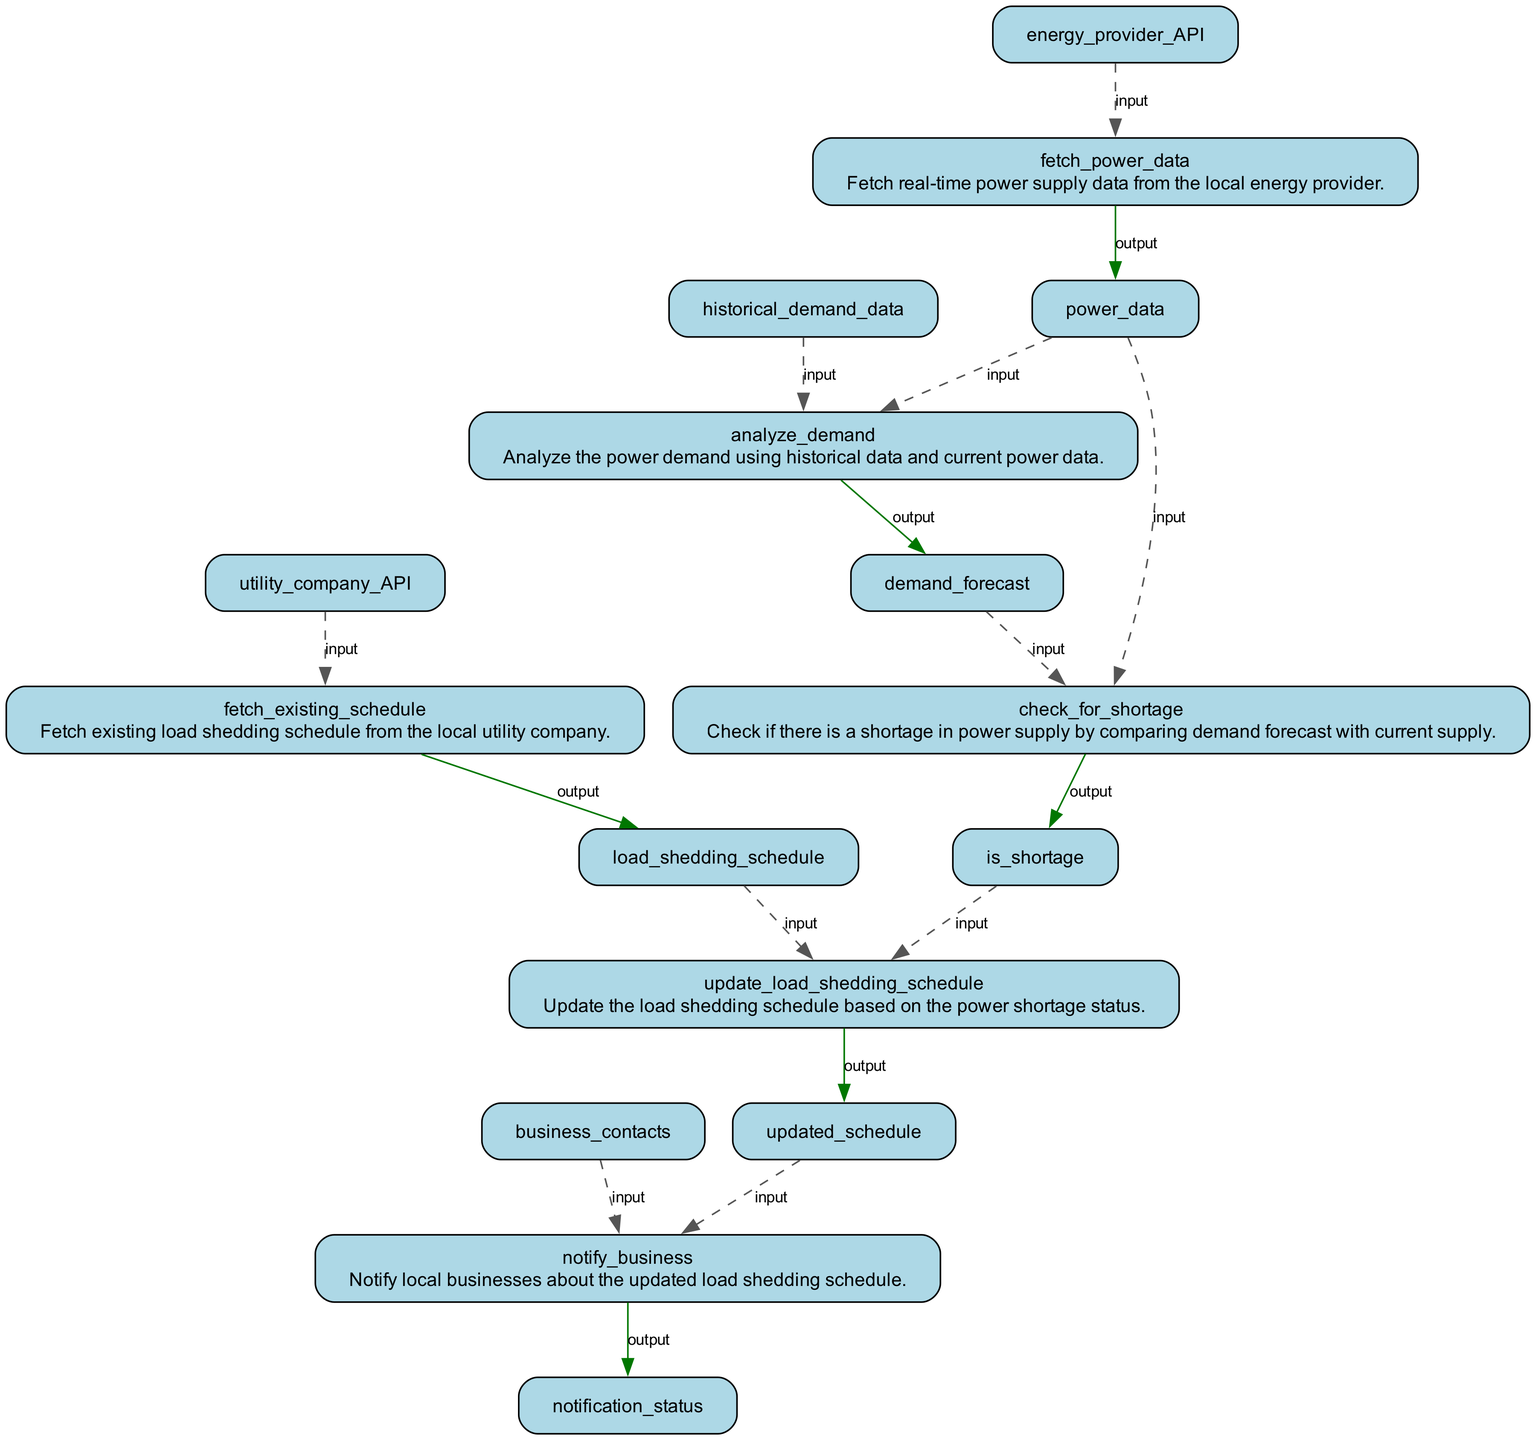What is the first function in the flowchart? The first function listed in the flowchart is "fetch_power_data". It is the starting point which fetches real-time data from the local energy provider.
Answer: fetch_power_data How many input items does "check_for_shortage" have? The node "check_for_shortage" has two input items: "demand_forecast" and "power_data". This means the function requires these two pieces of information to perform its operation.
Answer: 2 What is the output of the "notify_business" function? The output of the function "notify_business" is "notification_status". This indicates that the function will provide a status update after notifying businesses.
Answer: notification_status Which functions rely on real-time power data? The functions that rely on real-time power data are "analyze_demand" and "check_for_shortage". They both use the output from "fetch_power_data" to conduct their analyses.
Answer: analyze_demand, check_for_shortage If there is a power shortage, which function is responsible for updating the schedule? The function responsible for updating the schedule in case of a power shortage is "update_load_shedding_schedule". It takes the output of "check_for_shortage" as an input to adjust the existing schedule accordingly.
Answer: update_load_shedding_schedule Which node produces the "load_shedding_schedule"? The "fetch_existing_schedule" node produces the "load_shedding_schedule". This node is tasked with retrieving the current schedule from the local utility company.
Answer: fetch_existing_schedule What happens between "check_for_shortage" and "update_load_shedding_schedule"? Between these two functions, the result of "check_for_shortage" is used as an input for "update_load_shedding_schedule", which essentially determines whether an update to the existing schedule is needed based on whether there is a shortage.
Answer: Input check_for_shortage to update_load_shedding_schedule How many functions are responsible for fetching data? There are two functions responsible for fetching data: "fetch_power_data" and "fetch_existing_schedule". Each of these functions retrieves different types of data necessary for the overall system.
Answer: 2 What is the relationship between "update_load_shedding_schedule" and "notify_business"? "update_load_shedding_schedule" feeds its output, the "updated_schedule", to "notify_business". Therefore, the notification function acts upon the updated schedule provided by the preceding function.
Answer: updated_schedule 